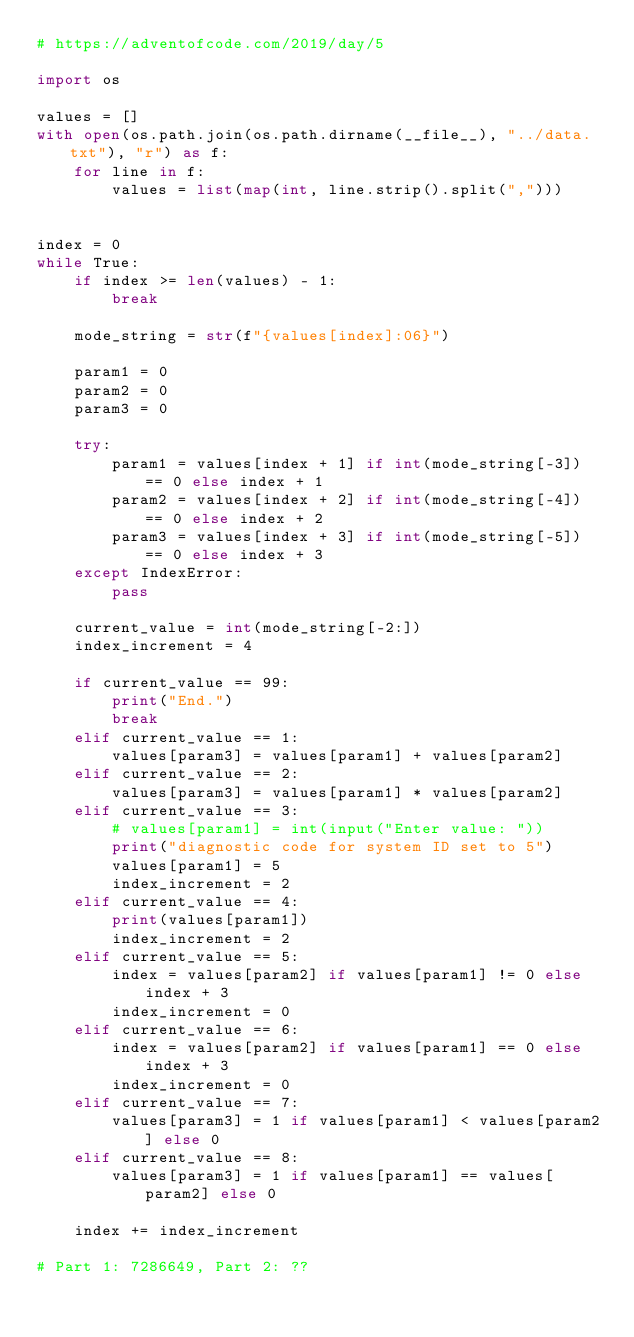Convert code to text. <code><loc_0><loc_0><loc_500><loc_500><_Python_># https://adventofcode.com/2019/day/5

import os

values = []
with open(os.path.join(os.path.dirname(__file__), "../data.txt"), "r") as f:
    for line in f:
        values = list(map(int, line.strip().split(",")))


index = 0
while True:
    if index >= len(values) - 1:
        break

    mode_string = str(f"{values[index]:06}")

    param1 = 0
    param2 = 0
    param3 = 0

    try:
        param1 = values[index + 1] if int(mode_string[-3]) == 0 else index + 1
        param2 = values[index + 2] if int(mode_string[-4]) == 0 else index + 2
        param3 = values[index + 3] if int(mode_string[-5]) == 0 else index + 3
    except IndexError:
        pass

    current_value = int(mode_string[-2:])
    index_increment = 4

    if current_value == 99:
        print("End.")
        break
    elif current_value == 1:
        values[param3] = values[param1] + values[param2]
    elif current_value == 2:
        values[param3] = values[param1] * values[param2]
    elif current_value == 3:
        # values[param1] = int(input("Enter value: "))
        print("diagnostic code for system ID set to 5")
        values[param1] = 5
        index_increment = 2
    elif current_value == 4:
        print(values[param1])
        index_increment = 2
    elif current_value == 5:
        index = values[param2] if values[param1] != 0 else index + 3
        index_increment = 0
    elif current_value == 6:
        index = values[param2] if values[param1] == 0 else index + 3
        index_increment = 0
    elif current_value == 7:
        values[param3] = 1 if values[param1] < values[param2] else 0
    elif current_value == 8:
        values[param3] = 1 if values[param1] == values[param2] else 0

    index += index_increment

# Part 1: 7286649, Part 2: ??
</code> 